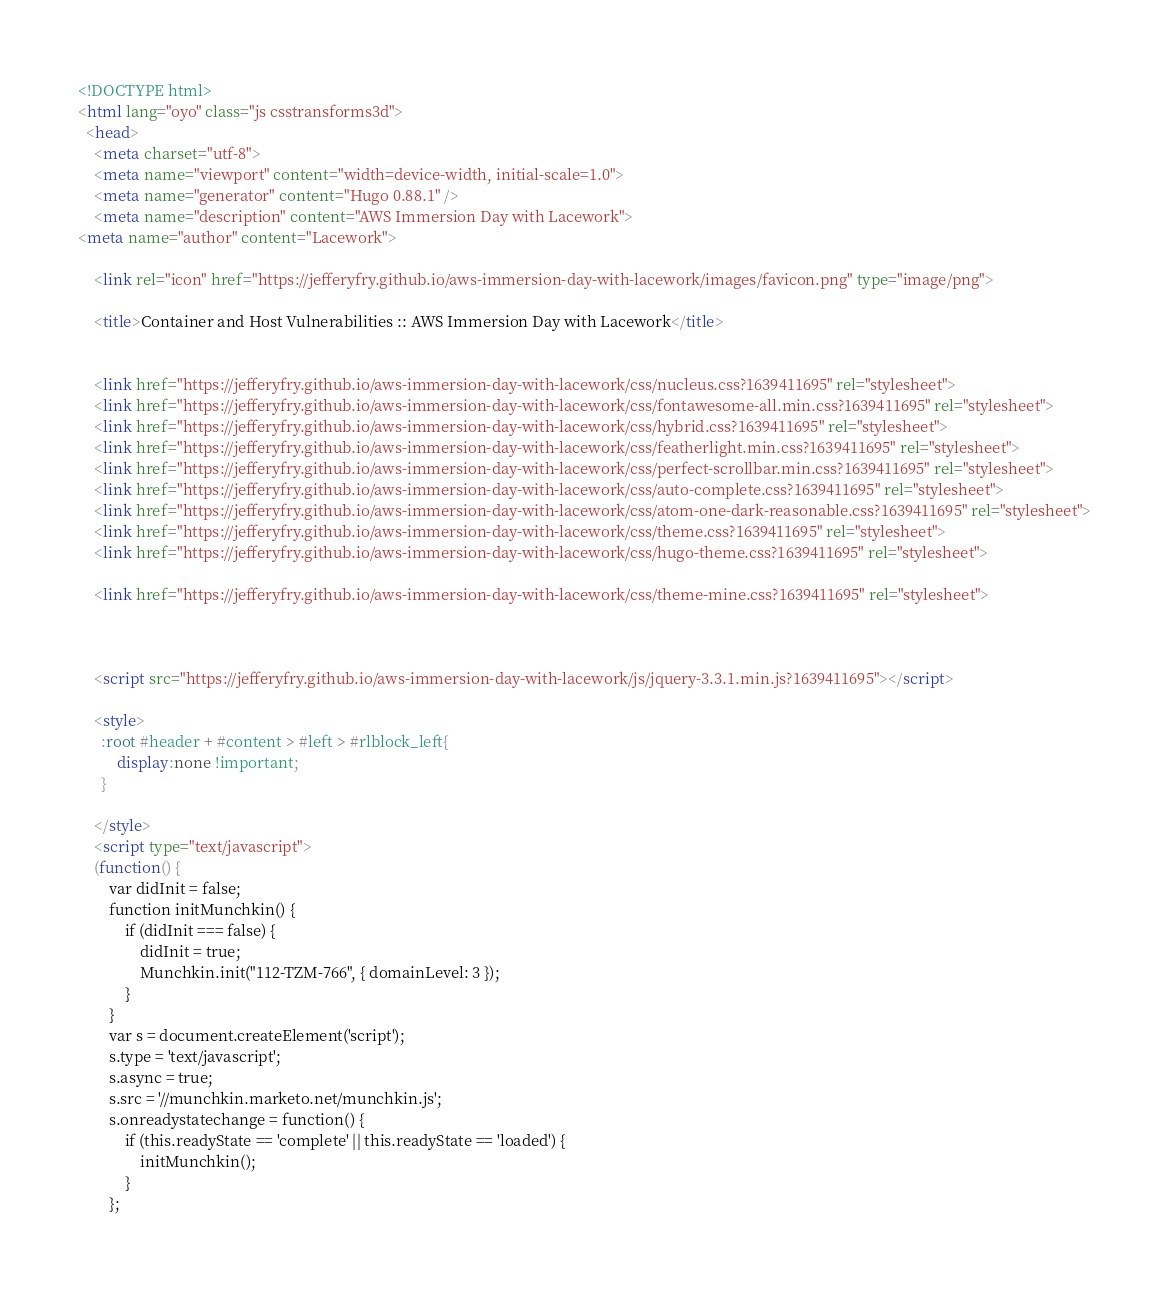Convert code to text. <code><loc_0><loc_0><loc_500><loc_500><_HTML_><!DOCTYPE html>
<html lang="oyo" class="js csstransforms3d">
  <head>
    <meta charset="utf-8">
    <meta name="viewport" content="width=device-width, initial-scale=1.0">
    <meta name="generator" content="Hugo 0.88.1" />
    <meta name="description" content="AWS Immersion Day with Lacework">
<meta name="author" content="Lacework">

    <link rel="icon" href="https://jefferyfry.github.io/aws-immersion-day-with-lacework/images/favicon.png" type="image/png">

    <title>Container and Host Vulnerabilities :: AWS Immersion Day with Lacework</title>

    
    <link href="https://jefferyfry.github.io/aws-immersion-day-with-lacework/css/nucleus.css?1639411695" rel="stylesheet">
    <link href="https://jefferyfry.github.io/aws-immersion-day-with-lacework/css/fontawesome-all.min.css?1639411695" rel="stylesheet">
    <link href="https://jefferyfry.github.io/aws-immersion-day-with-lacework/css/hybrid.css?1639411695" rel="stylesheet">
    <link href="https://jefferyfry.github.io/aws-immersion-day-with-lacework/css/featherlight.min.css?1639411695" rel="stylesheet">
    <link href="https://jefferyfry.github.io/aws-immersion-day-with-lacework/css/perfect-scrollbar.min.css?1639411695" rel="stylesheet">
    <link href="https://jefferyfry.github.io/aws-immersion-day-with-lacework/css/auto-complete.css?1639411695" rel="stylesheet">
    <link href="https://jefferyfry.github.io/aws-immersion-day-with-lacework/css/atom-one-dark-reasonable.css?1639411695" rel="stylesheet">
    <link href="https://jefferyfry.github.io/aws-immersion-day-with-lacework/css/theme.css?1639411695" rel="stylesheet">
    <link href="https://jefferyfry.github.io/aws-immersion-day-with-lacework/css/hugo-theme.css?1639411695" rel="stylesheet">
    
    <link href="https://jefferyfry.github.io/aws-immersion-day-with-lacework/css/theme-mine.css?1639411695" rel="stylesheet">
    
    

    <script src="https://jefferyfry.github.io/aws-immersion-day-with-lacework/js/jquery-3.3.1.min.js?1639411695"></script>

    <style>
      :root #header + #content > #left > #rlblock_left{
          display:none !important;
      }
      
    </style>
    <script type="text/javascript">
    (function() {
        var didInit = false;
        function initMunchkin() {
            if (didInit === false) {
                didInit = true;
                Munchkin.init("112-TZM-766", { domainLevel: 3 });
            }
        }
        var s = document.createElement('script');
        s.type = 'text/javascript';
        s.async = true;
        s.src = '//munchkin.marketo.net/munchkin.js';
        s.onreadystatechange = function() {
            if (this.readyState == 'complete' || this.readyState == 'loaded') {
                initMunchkin();
            }
        };</code> 